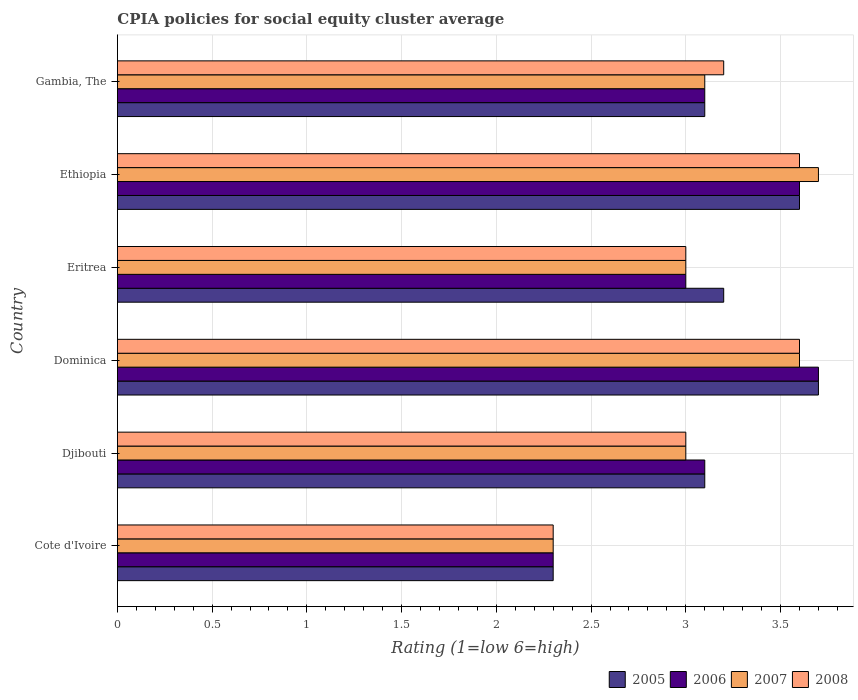How many groups of bars are there?
Your response must be concise. 6. Are the number of bars on each tick of the Y-axis equal?
Provide a succinct answer. Yes. How many bars are there on the 1st tick from the top?
Ensure brevity in your answer.  4. What is the label of the 1st group of bars from the top?
Ensure brevity in your answer.  Gambia, The. In how many cases, is the number of bars for a given country not equal to the number of legend labels?
Make the answer very short. 0. What is the CPIA rating in 2006 in Ethiopia?
Give a very brief answer. 3.6. Across all countries, what is the maximum CPIA rating in 2006?
Keep it short and to the point. 3.7. In which country was the CPIA rating in 2008 maximum?
Keep it short and to the point. Dominica. In which country was the CPIA rating in 2006 minimum?
Offer a terse response. Cote d'Ivoire. What is the difference between the CPIA rating in 2007 in Ethiopia and that in Gambia, The?
Offer a very short reply. 0.6. What is the difference between the CPIA rating in 2007 in Eritrea and the CPIA rating in 2006 in Ethiopia?
Provide a short and direct response. -0.6. What is the average CPIA rating in 2007 per country?
Your response must be concise. 3.12. What is the ratio of the CPIA rating in 2005 in Djibouti to that in Eritrea?
Make the answer very short. 0.97. Is the CPIA rating in 2008 in Djibouti less than that in Eritrea?
Give a very brief answer. No. What is the difference between the highest and the second highest CPIA rating in 2007?
Keep it short and to the point. 0.1. What is the difference between the highest and the lowest CPIA rating in 2006?
Provide a short and direct response. 1.4. In how many countries, is the CPIA rating in 2006 greater than the average CPIA rating in 2006 taken over all countries?
Offer a terse response. 2. What does the 1st bar from the top in Eritrea represents?
Provide a short and direct response. 2008. What does the 1st bar from the bottom in Djibouti represents?
Keep it short and to the point. 2005. Is it the case that in every country, the sum of the CPIA rating in 2005 and CPIA rating in 2007 is greater than the CPIA rating in 2006?
Ensure brevity in your answer.  Yes. Are all the bars in the graph horizontal?
Provide a short and direct response. Yes. What is the difference between two consecutive major ticks on the X-axis?
Provide a short and direct response. 0.5. Are the values on the major ticks of X-axis written in scientific E-notation?
Offer a terse response. No. How many legend labels are there?
Your response must be concise. 4. How are the legend labels stacked?
Your answer should be compact. Horizontal. What is the title of the graph?
Your answer should be very brief. CPIA policies for social equity cluster average. What is the label or title of the X-axis?
Your answer should be very brief. Rating (1=low 6=high). What is the Rating (1=low 6=high) of 2005 in Cote d'Ivoire?
Keep it short and to the point. 2.3. What is the Rating (1=low 6=high) of 2005 in Djibouti?
Your response must be concise. 3.1. What is the Rating (1=low 6=high) of 2006 in Djibouti?
Provide a succinct answer. 3.1. What is the Rating (1=low 6=high) in 2007 in Djibouti?
Your answer should be compact. 3. What is the Rating (1=low 6=high) in 2008 in Djibouti?
Your answer should be very brief. 3. What is the Rating (1=low 6=high) of 2005 in Dominica?
Your answer should be compact. 3.7. What is the Rating (1=low 6=high) in 2006 in Dominica?
Your answer should be very brief. 3.7. What is the Rating (1=low 6=high) of 2008 in Dominica?
Keep it short and to the point. 3.6. What is the Rating (1=low 6=high) of 2005 in Eritrea?
Offer a terse response. 3.2. What is the Rating (1=low 6=high) in 2007 in Eritrea?
Your answer should be compact. 3. What is the Rating (1=low 6=high) in 2008 in Eritrea?
Keep it short and to the point. 3. What is the Rating (1=low 6=high) of 2005 in Ethiopia?
Your response must be concise. 3.6. What is the Rating (1=low 6=high) in 2006 in Ethiopia?
Your answer should be very brief. 3.6. What is the Rating (1=low 6=high) of 2008 in Ethiopia?
Provide a short and direct response. 3.6. What is the Rating (1=low 6=high) in 2006 in Gambia, The?
Ensure brevity in your answer.  3.1. What is the Rating (1=low 6=high) of 2007 in Gambia, The?
Your response must be concise. 3.1. What is the Rating (1=low 6=high) of 2008 in Gambia, The?
Give a very brief answer. 3.2. Across all countries, what is the maximum Rating (1=low 6=high) in 2005?
Provide a succinct answer. 3.7. Across all countries, what is the maximum Rating (1=low 6=high) of 2006?
Make the answer very short. 3.7. Across all countries, what is the minimum Rating (1=low 6=high) of 2006?
Provide a short and direct response. 2.3. Across all countries, what is the minimum Rating (1=low 6=high) of 2007?
Make the answer very short. 2.3. Across all countries, what is the minimum Rating (1=low 6=high) in 2008?
Your answer should be very brief. 2.3. What is the total Rating (1=low 6=high) in 2005 in the graph?
Ensure brevity in your answer.  19. What is the total Rating (1=low 6=high) in 2007 in the graph?
Your answer should be compact. 18.7. What is the total Rating (1=low 6=high) of 2008 in the graph?
Your response must be concise. 18.7. What is the difference between the Rating (1=low 6=high) of 2006 in Cote d'Ivoire and that in Djibouti?
Ensure brevity in your answer.  -0.8. What is the difference between the Rating (1=low 6=high) of 2006 in Cote d'Ivoire and that in Dominica?
Provide a short and direct response. -1.4. What is the difference between the Rating (1=low 6=high) of 2008 in Cote d'Ivoire and that in Ethiopia?
Provide a succinct answer. -1.3. What is the difference between the Rating (1=low 6=high) of 2005 in Cote d'Ivoire and that in Gambia, The?
Offer a very short reply. -0.8. What is the difference between the Rating (1=low 6=high) in 2006 in Cote d'Ivoire and that in Gambia, The?
Give a very brief answer. -0.8. What is the difference between the Rating (1=low 6=high) of 2007 in Cote d'Ivoire and that in Gambia, The?
Offer a very short reply. -0.8. What is the difference between the Rating (1=low 6=high) in 2006 in Djibouti and that in Dominica?
Make the answer very short. -0.6. What is the difference between the Rating (1=low 6=high) of 2007 in Djibouti and that in Dominica?
Keep it short and to the point. -0.6. What is the difference between the Rating (1=low 6=high) in 2008 in Djibouti and that in Eritrea?
Your answer should be very brief. 0. What is the difference between the Rating (1=low 6=high) of 2005 in Djibouti and that in Ethiopia?
Ensure brevity in your answer.  -0.5. What is the difference between the Rating (1=low 6=high) in 2006 in Djibouti and that in Ethiopia?
Your answer should be compact. -0.5. What is the difference between the Rating (1=low 6=high) in 2007 in Djibouti and that in Ethiopia?
Ensure brevity in your answer.  -0.7. What is the difference between the Rating (1=low 6=high) of 2008 in Djibouti and that in Gambia, The?
Offer a terse response. -0.2. What is the difference between the Rating (1=low 6=high) in 2006 in Dominica and that in Eritrea?
Keep it short and to the point. 0.7. What is the difference between the Rating (1=low 6=high) in 2005 in Dominica and that in Ethiopia?
Offer a terse response. 0.1. What is the difference between the Rating (1=low 6=high) in 2007 in Dominica and that in Ethiopia?
Your answer should be compact. -0.1. What is the difference between the Rating (1=low 6=high) of 2005 in Dominica and that in Gambia, The?
Provide a short and direct response. 0.6. What is the difference between the Rating (1=low 6=high) in 2006 in Dominica and that in Gambia, The?
Provide a short and direct response. 0.6. What is the difference between the Rating (1=low 6=high) in 2008 in Dominica and that in Gambia, The?
Provide a succinct answer. 0.4. What is the difference between the Rating (1=low 6=high) of 2005 in Eritrea and that in Ethiopia?
Your response must be concise. -0.4. What is the difference between the Rating (1=low 6=high) in 2006 in Eritrea and that in Ethiopia?
Offer a terse response. -0.6. What is the difference between the Rating (1=low 6=high) in 2007 in Eritrea and that in Ethiopia?
Your answer should be compact. -0.7. What is the difference between the Rating (1=low 6=high) of 2008 in Eritrea and that in Ethiopia?
Keep it short and to the point. -0.6. What is the difference between the Rating (1=low 6=high) of 2006 in Eritrea and that in Gambia, The?
Your answer should be compact. -0.1. What is the difference between the Rating (1=low 6=high) in 2007 in Eritrea and that in Gambia, The?
Keep it short and to the point. -0.1. What is the difference between the Rating (1=low 6=high) in 2006 in Ethiopia and that in Gambia, The?
Keep it short and to the point. 0.5. What is the difference between the Rating (1=low 6=high) in 2005 in Cote d'Ivoire and the Rating (1=low 6=high) in 2006 in Djibouti?
Make the answer very short. -0.8. What is the difference between the Rating (1=low 6=high) in 2005 in Cote d'Ivoire and the Rating (1=low 6=high) in 2007 in Djibouti?
Make the answer very short. -0.7. What is the difference between the Rating (1=low 6=high) of 2007 in Cote d'Ivoire and the Rating (1=low 6=high) of 2008 in Djibouti?
Provide a succinct answer. -0.7. What is the difference between the Rating (1=low 6=high) of 2005 in Cote d'Ivoire and the Rating (1=low 6=high) of 2006 in Dominica?
Offer a terse response. -1.4. What is the difference between the Rating (1=low 6=high) of 2005 in Cote d'Ivoire and the Rating (1=low 6=high) of 2007 in Dominica?
Your answer should be compact. -1.3. What is the difference between the Rating (1=low 6=high) of 2006 in Cote d'Ivoire and the Rating (1=low 6=high) of 2007 in Dominica?
Make the answer very short. -1.3. What is the difference between the Rating (1=low 6=high) of 2006 in Cote d'Ivoire and the Rating (1=low 6=high) of 2008 in Dominica?
Keep it short and to the point. -1.3. What is the difference between the Rating (1=low 6=high) of 2006 in Cote d'Ivoire and the Rating (1=low 6=high) of 2008 in Eritrea?
Your response must be concise. -0.7. What is the difference between the Rating (1=low 6=high) in 2007 in Cote d'Ivoire and the Rating (1=low 6=high) in 2008 in Eritrea?
Keep it short and to the point. -0.7. What is the difference between the Rating (1=low 6=high) in 2005 in Cote d'Ivoire and the Rating (1=low 6=high) in 2007 in Ethiopia?
Offer a terse response. -1.4. What is the difference between the Rating (1=low 6=high) of 2005 in Cote d'Ivoire and the Rating (1=low 6=high) of 2008 in Gambia, The?
Your response must be concise. -0.9. What is the difference between the Rating (1=low 6=high) of 2007 in Cote d'Ivoire and the Rating (1=low 6=high) of 2008 in Gambia, The?
Ensure brevity in your answer.  -0.9. What is the difference between the Rating (1=low 6=high) in 2005 in Djibouti and the Rating (1=low 6=high) in 2006 in Dominica?
Your answer should be compact. -0.6. What is the difference between the Rating (1=low 6=high) in 2006 in Djibouti and the Rating (1=low 6=high) in 2008 in Dominica?
Your response must be concise. -0.5. What is the difference between the Rating (1=low 6=high) of 2005 in Djibouti and the Rating (1=low 6=high) of 2007 in Eritrea?
Your response must be concise. 0.1. What is the difference between the Rating (1=low 6=high) of 2006 in Djibouti and the Rating (1=low 6=high) of 2007 in Eritrea?
Provide a short and direct response. 0.1. What is the difference between the Rating (1=low 6=high) in 2006 in Djibouti and the Rating (1=low 6=high) in 2008 in Eritrea?
Your answer should be very brief. 0.1. What is the difference between the Rating (1=low 6=high) in 2005 in Djibouti and the Rating (1=low 6=high) in 2007 in Ethiopia?
Make the answer very short. -0.6. What is the difference between the Rating (1=low 6=high) of 2007 in Djibouti and the Rating (1=low 6=high) of 2008 in Ethiopia?
Ensure brevity in your answer.  -0.6. What is the difference between the Rating (1=low 6=high) in 2005 in Djibouti and the Rating (1=low 6=high) in 2006 in Gambia, The?
Keep it short and to the point. 0. What is the difference between the Rating (1=low 6=high) of 2005 in Djibouti and the Rating (1=low 6=high) of 2007 in Gambia, The?
Ensure brevity in your answer.  0. What is the difference between the Rating (1=low 6=high) of 2006 in Djibouti and the Rating (1=low 6=high) of 2008 in Gambia, The?
Make the answer very short. -0.1. What is the difference between the Rating (1=low 6=high) of 2007 in Djibouti and the Rating (1=low 6=high) of 2008 in Gambia, The?
Your answer should be compact. -0.2. What is the difference between the Rating (1=low 6=high) in 2005 in Dominica and the Rating (1=low 6=high) in 2007 in Eritrea?
Provide a short and direct response. 0.7. What is the difference between the Rating (1=low 6=high) of 2006 in Dominica and the Rating (1=low 6=high) of 2008 in Eritrea?
Give a very brief answer. 0.7. What is the difference between the Rating (1=low 6=high) in 2005 in Dominica and the Rating (1=low 6=high) in 2006 in Ethiopia?
Keep it short and to the point. 0.1. What is the difference between the Rating (1=low 6=high) in 2005 in Dominica and the Rating (1=low 6=high) in 2007 in Ethiopia?
Offer a very short reply. 0. What is the difference between the Rating (1=low 6=high) of 2006 in Dominica and the Rating (1=low 6=high) of 2007 in Ethiopia?
Ensure brevity in your answer.  0. What is the difference between the Rating (1=low 6=high) of 2005 in Dominica and the Rating (1=low 6=high) of 2006 in Gambia, The?
Give a very brief answer. 0.6. What is the difference between the Rating (1=low 6=high) of 2005 in Dominica and the Rating (1=low 6=high) of 2008 in Gambia, The?
Make the answer very short. 0.5. What is the difference between the Rating (1=low 6=high) of 2006 in Dominica and the Rating (1=low 6=high) of 2007 in Gambia, The?
Make the answer very short. 0.6. What is the difference between the Rating (1=low 6=high) in 2005 in Eritrea and the Rating (1=low 6=high) in 2006 in Ethiopia?
Your answer should be very brief. -0.4. What is the difference between the Rating (1=low 6=high) of 2005 in Eritrea and the Rating (1=low 6=high) of 2007 in Ethiopia?
Provide a succinct answer. -0.5. What is the difference between the Rating (1=low 6=high) of 2005 in Eritrea and the Rating (1=low 6=high) of 2008 in Ethiopia?
Your answer should be compact. -0.4. What is the difference between the Rating (1=low 6=high) in 2006 in Eritrea and the Rating (1=low 6=high) in 2008 in Ethiopia?
Your response must be concise. -0.6. What is the difference between the Rating (1=low 6=high) of 2007 in Eritrea and the Rating (1=low 6=high) of 2008 in Ethiopia?
Your answer should be very brief. -0.6. What is the difference between the Rating (1=low 6=high) in 2005 in Eritrea and the Rating (1=low 6=high) in 2007 in Gambia, The?
Make the answer very short. 0.1. What is the difference between the Rating (1=low 6=high) in 2005 in Eritrea and the Rating (1=low 6=high) in 2008 in Gambia, The?
Keep it short and to the point. 0. What is the difference between the Rating (1=low 6=high) in 2005 in Ethiopia and the Rating (1=low 6=high) in 2006 in Gambia, The?
Your answer should be very brief. 0.5. What is the difference between the Rating (1=low 6=high) in 2006 in Ethiopia and the Rating (1=low 6=high) in 2007 in Gambia, The?
Your answer should be compact. 0.5. What is the difference between the Rating (1=low 6=high) of 2006 in Ethiopia and the Rating (1=low 6=high) of 2008 in Gambia, The?
Your response must be concise. 0.4. What is the average Rating (1=low 6=high) in 2005 per country?
Ensure brevity in your answer.  3.17. What is the average Rating (1=low 6=high) in 2006 per country?
Keep it short and to the point. 3.13. What is the average Rating (1=low 6=high) of 2007 per country?
Ensure brevity in your answer.  3.12. What is the average Rating (1=low 6=high) in 2008 per country?
Make the answer very short. 3.12. What is the difference between the Rating (1=low 6=high) of 2005 and Rating (1=low 6=high) of 2006 in Cote d'Ivoire?
Provide a short and direct response. 0. What is the difference between the Rating (1=low 6=high) in 2005 and Rating (1=low 6=high) in 2008 in Cote d'Ivoire?
Provide a succinct answer. 0. What is the difference between the Rating (1=low 6=high) of 2006 and Rating (1=low 6=high) of 2007 in Cote d'Ivoire?
Your answer should be compact. 0. What is the difference between the Rating (1=low 6=high) in 2006 and Rating (1=low 6=high) in 2008 in Cote d'Ivoire?
Provide a short and direct response. 0. What is the difference between the Rating (1=low 6=high) in 2007 and Rating (1=low 6=high) in 2008 in Cote d'Ivoire?
Your response must be concise. 0. What is the difference between the Rating (1=low 6=high) in 2005 and Rating (1=low 6=high) in 2008 in Djibouti?
Provide a short and direct response. 0.1. What is the difference between the Rating (1=low 6=high) of 2006 and Rating (1=low 6=high) of 2007 in Djibouti?
Your response must be concise. 0.1. What is the difference between the Rating (1=low 6=high) in 2006 and Rating (1=low 6=high) in 2008 in Djibouti?
Give a very brief answer. 0.1. What is the difference between the Rating (1=low 6=high) of 2007 and Rating (1=low 6=high) of 2008 in Djibouti?
Your answer should be very brief. 0. What is the difference between the Rating (1=low 6=high) in 2005 and Rating (1=low 6=high) in 2006 in Dominica?
Give a very brief answer. 0. What is the difference between the Rating (1=low 6=high) in 2005 and Rating (1=low 6=high) in 2008 in Dominica?
Offer a very short reply. 0.1. What is the difference between the Rating (1=low 6=high) of 2006 and Rating (1=low 6=high) of 2008 in Dominica?
Make the answer very short. 0.1. What is the difference between the Rating (1=low 6=high) in 2006 and Rating (1=low 6=high) in 2007 in Eritrea?
Provide a succinct answer. 0. What is the difference between the Rating (1=low 6=high) in 2006 and Rating (1=low 6=high) in 2008 in Ethiopia?
Make the answer very short. 0. What is the difference between the Rating (1=low 6=high) of 2007 and Rating (1=low 6=high) of 2008 in Ethiopia?
Give a very brief answer. 0.1. What is the difference between the Rating (1=low 6=high) in 2005 and Rating (1=low 6=high) in 2008 in Gambia, The?
Offer a terse response. -0.1. What is the difference between the Rating (1=low 6=high) of 2006 and Rating (1=low 6=high) of 2007 in Gambia, The?
Offer a terse response. 0. What is the difference between the Rating (1=low 6=high) in 2006 and Rating (1=low 6=high) in 2008 in Gambia, The?
Provide a succinct answer. -0.1. What is the difference between the Rating (1=low 6=high) of 2007 and Rating (1=low 6=high) of 2008 in Gambia, The?
Keep it short and to the point. -0.1. What is the ratio of the Rating (1=low 6=high) in 2005 in Cote d'Ivoire to that in Djibouti?
Offer a very short reply. 0.74. What is the ratio of the Rating (1=low 6=high) in 2006 in Cote d'Ivoire to that in Djibouti?
Make the answer very short. 0.74. What is the ratio of the Rating (1=low 6=high) in 2007 in Cote d'Ivoire to that in Djibouti?
Keep it short and to the point. 0.77. What is the ratio of the Rating (1=low 6=high) in 2008 in Cote d'Ivoire to that in Djibouti?
Your response must be concise. 0.77. What is the ratio of the Rating (1=low 6=high) of 2005 in Cote d'Ivoire to that in Dominica?
Offer a terse response. 0.62. What is the ratio of the Rating (1=low 6=high) in 2006 in Cote d'Ivoire to that in Dominica?
Offer a very short reply. 0.62. What is the ratio of the Rating (1=low 6=high) of 2007 in Cote d'Ivoire to that in Dominica?
Your answer should be compact. 0.64. What is the ratio of the Rating (1=low 6=high) of 2008 in Cote d'Ivoire to that in Dominica?
Provide a short and direct response. 0.64. What is the ratio of the Rating (1=low 6=high) of 2005 in Cote d'Ivoire to that in Eritrea?
Provide a succinct answer. 0.72. What is the ratio of the Rating (1=low 6=high) of 2006 in Cote d'Ivoire to that in Eritrea?
Your answer should be very brief. 0.77. What is the ratio of the Rating (1=low 6=high) of 2007 in Cote d'Ivoire to that in Eritrea?
Give a very brief answer. 0.77. What is the ratio of the Rating (1=low 6=high) in 2008 in Cote d'Ivoire to that in Eritrea?
Your answer should be compact. 0.77. What is the ratio of the Rating (1=low 6=high) in 2005 in Cote d'Ivoire to that in Ethiopia?
Give a very brief answer. 0.64. What is the ratio of the Rating (1=low 6=high) of 2006 in Cote d'Ivoire to that in Ethiopia?
Provide a short and direct response. 0.64. What is the ratio of the Rating (1=low 6=high) of 2007 in Cote d'Ivoire to that in Ethiopia?
Give a very brief answer. 0.62. What is the ratio of the Rating (1=low 6=high) of 2008 in Cote d'Ivoire to that in Ethiopia?
Make the answer very short. 0.64. What is the ratio of the Rating (1=low 6=high) of 2005 in Cote d'Ivoire to that in Gambia, The?
Keep it short and to the point. 0.74. What is the ratio of the Rating (1=low 6=high) in 2006 in Cote d'Ivoire to that in Gambia, The?
Offer a terse response. 0.74. What is the ratio of the Rating (1=low 6=high) of 2007 in Cote d'Ivoire to that in Gambia, The?
Make the answer very short. 0.74. What is the ratio of the Rating (1=low 6=high) in 2008 in Cote d'Ivoire to that in Gambia, The?
Your response must be concise. 0.72. What is the ratio of the Rating (1=low 6=high) of 2005 in Djibouti to that in Dominica?
Ensure brevity in your answer.  0.84. What is the ratio of the Rating (1=low 6=high) in 2006 in Djibouti to that in Dominica?
Your response must be concise. 0.84. What is the ratio of the Rating (1=low 6=high) of 2005 in Djibouti to that in Eritrea?
Your response must be concise. 0.97. What is the ratio of the Rating (1=low 6=high) of 2007 in Djibouti to that in Eritrea?
Give a very brief answer. 1. What is the ratio of the Rating (1=low 6=high) in 2008 in Djibouti to that in Eritrea?
Offer a very short reply. 1. What is the ratio of the Rating (1=low 6=high) in 2005 in Djibouti to that in Ethiopia?
Keep it short and to the point. 0.86. What is the ratio of the Rating (1=low 6=high) of 2006 in Djibouti to that in Ethiopia?
Keep it short and to the point. 0.86. What is the ratio of the Rating (1=low 6=high) in 2007 in Djibouti to that in Ethiopia?
Provide a succinct answer. 0.81. What is the ratio of the Rating (1=low 6=high) in 2005 in Djibouti to that in Gambia, The?
Offer a very short reply. 1. What is the ratio of the Rating (1=low 6=high) of 2006 in Djibouti to that in Gambia, The?
Your response must be concise. 1. What is the ratio of the Rating (1=low 6=high) of 2008 in Djibouti to that in Gambia, The?
Give a very brief answer. 0.94. What is the ratio of the Rating (1=low 6=high) in 2005 in Dominica to that in Eritrea?
Give a very brief answer. 1.16. What is the ratio of the Rating (1=low 6=high) in 2006 in Dominica to that in Eritrea?
Keep it short and to the point. 1.23. What is the ratio of the Rating (1=low 6=high) of 2008 in Dominica to that in Eritrea?
Keep it short and to the point. 1.2. What is the ratio of the Rating (1=low 6=high) of 2005 in Dominica to that in Ethiopia?
Offer a terse response. 1.03. What is the ratio of the Rating (1=low 6=high) of 2006 in Dominica to that in Ethiopia?
Ensure brevity in your answer.  1.03. What is the ratio of the Rating (1=low 6=high) of 2007 in Dominica to that in Ethiopia?
Ensure brevity in your answer.  0.97. What is the ratio of the Rating (1=low 6=high) of 2005 in Dominica to that in Gambia, The?
Your answer should be compact. 1.19. What is the ratio of the Rating (1=low 6=high) in 2006 in Dominica to that in Gambia, The?
Offer a terse response. 1.19. What is the ratio of the Rating (1=low 6=high) of 2007 in Dominica to that in Gambia, The?
Your response must be concise. 1.16. What is the ratio of the Rating (1=low 6=high) of 2008 in Dominica to that in Gambia, The?
Provide a short and direct response. 1.12. What is the ratio of the Rating (1=low 6=high) in 2005 in Eritrea to that in Ethiopia?
Make the answer very short. 0.89. What is the ratio of the Rating (1=low 6=high) of 2006 in Eritrea to that in Ethiopia?
Keep it short and to the point. 0.83. What is the ratio of the Rating (1=low 6=high) of 2007 in Eritrea to that in Ethiopia?
Provide a short and direct response. 0.81. What is the ratio of the Rating (1=low 6=high) of 2005 in Eritrea to that in Gambia, The?
Offer a terse response. 1.03. What is the ratio of the Rating (1=low 6=high) in 2006 in Eritrea to that in Gambia, The?
Your answer should be very brief. 0.97. What is the ratio of the Rating (1=low 6=high) in 2007 in Eritrea to that in Gambia, The?
Give a very brief answer. 0.97. What is the ratio of the Rating (1=low 6=high) of 2008 in Eritrea to that in Gambia, The?
Give a very brief answer. 0.94. What is the ratio of the Rating (1=low 6=high) in 2005 in Ethiopia to that in Gambia, The?
Make the answer very short. 1.16. What is the ratio of the Rating (1=low 6=high) in 2006 in Ethiopia to that in Gambia, The?
Ensure brevity in your answer.  1.16. What is the ratio of the Rating (1=low 6=high) of 2007 in Ethiopia to that in Gambia, The?
Offer a terse response. 1.19. What is the ratio of the Rating (1=low 6=high) of 2008 in Ethiopia to that in Gambia, The?
Give a very brief answer. 1.12. What is the difference between the highest and the second highest Rating (1=low 6=high) of 2007?
Your answer should be compact. 0.1. What is the difference between the highest and the second highest Rating (1=low 6=high) of 2008?
Make the answer very short. 0. What is the difference between the highest and the lowest Rating (1=low 6=high) of 2006?
Keep it short and to the point. 1.4. What is the difference between the highest and the lowest Rating (1=low 6=high) of 2007?
Keep it short and to the point. 1.4. What is the difference between the highest and the lowest Rating (1=low 6=high) in 2008?
Ensure brevity in your answer.  1.3. 